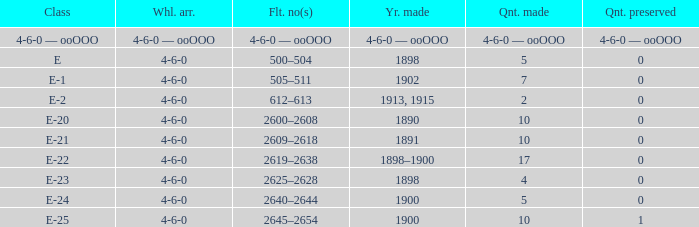What is the wheel arrangement with 1 quantity preserved? 4-6-0. 